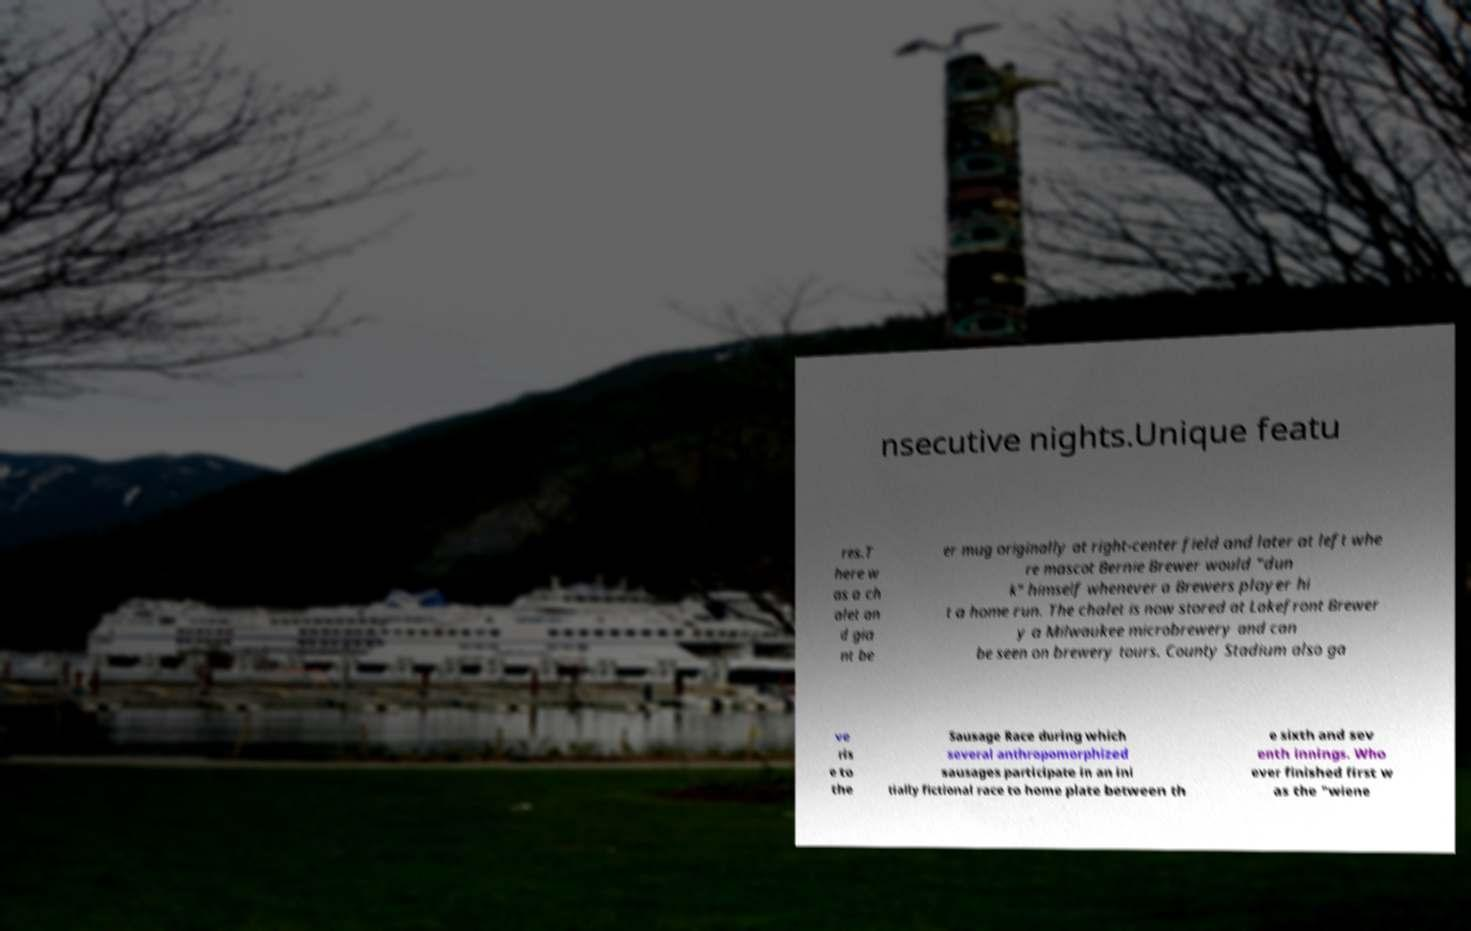Could you assist in decoding the text presented in this image and type it out clearly? nsecutive nights.Unique featu res.T here w as a ch alet an d gia nt be er mug originally at right-center field and later at left whe re mascot Bernie Brewer would "dun k" himself whenever a Brewers player hi t a home run. The chalet is now stored at Lakefront Brewer y a Milwaukee microbrewery and can be seen on brewery tours. County Stadium also ga ve ris e to the Sausage Race during which several anthropomorphized sausages participate in an ini tially fictional race to home plate between th e sixth and sev enth innings. Who ever finished first w as the "wiene 